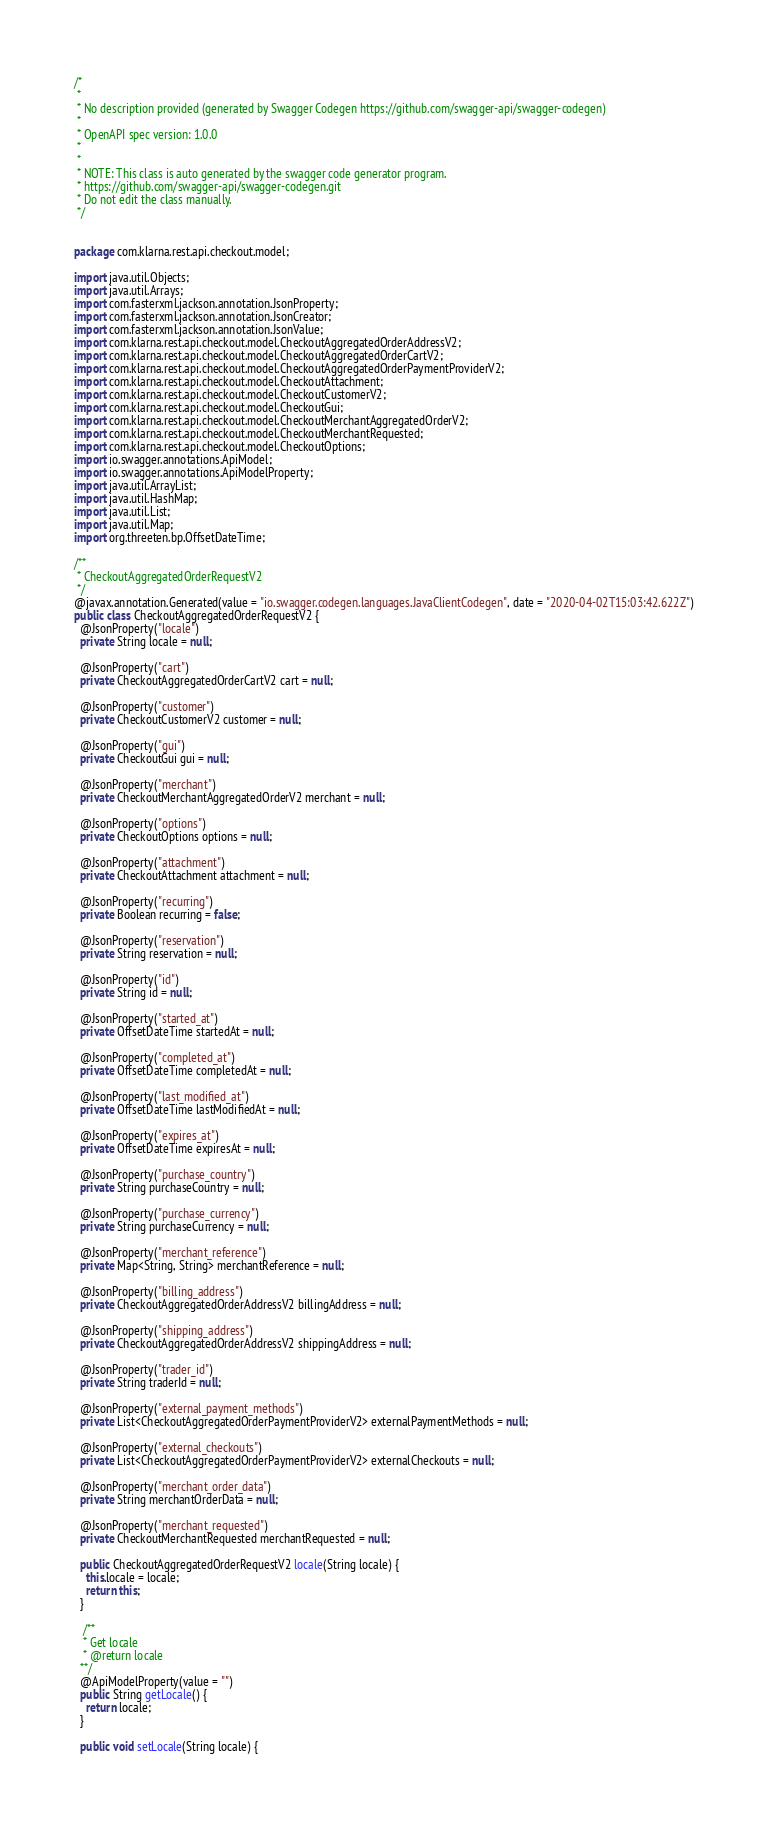Convert code to text. <code><loc_0><loc_0><loc_500><loc_500><_Java_>/*
 * 
 * No description provided (generated by Swagger Codegen https://github.com/swagger-api/swagger-codegen)
 *
 * OpenAPI spec version: 1.0.0
 * 
 *
 * NOTE: This class is auto generated by the swagger code generator program.
 * https://github.com/swagger-api/swagger-codegen.git
 * Do not edit the class manually.
 */


package com.klarna.rest.api.checkout.model;

import java.util.Objects;
import java.util.Arrays;
import com.fasterxml.jackson.annotation.JsonProperty;
import com.fasterxml.jackson.annotation.JsonCreator;
import com.fasterxml.jackson.annotation.JsonValue;
import com.klarna.rest.api.checkout.model.CheckoutAggregatedOrderAddressV2;
import com.klarna.rest.api.checkout.model.CheckoutAggregatedOrderCartV2;
import com.klarna.rest.api.checkout.model.CheckoutAggregatedOrderPaymentProviderV2;
import com.klarna.rest.api.checkout.model.CheckoutAttachment;
import com.klarna.rest.api.checkout.model.CheckoutCustomerV2;
import com.klarna.rest.api.checkout.model.CheckoutGui;
import com.klarna.rest.api.checkout.model.CheckoutMerchantAggregatedOrderV2;
import com.klarna.rest.api.checkout.model.CheckoutMerchantRequested;
import com.klarna.rest.api.checkout.model.CheckoutOptions;
import io.swagger.annotations.ApiModel;
import io.swagger.annotations.ApiModelProperty;
import java.util.ArrayList;
import java.util.HashMap;
import java.util.List;
import java.util.Map;
import org.threeten.bp.OffsetDateTime;

/**
 * CheckoutAggregatedOrderRequestV2
 */
@javax.annotation.Generated(value = "io.swagger.codegen.languages.JavaClientCodegen", date = "2020-04-02T15:03:42.622Z")
public class CheckoutAggregatedOrderRequestV2 {
  @JsonProperty("locale")
  private String locale = null;

  @JsonProperty("cart")
  private CheckoutAggregatedOrderCartV2 cart = null;

  @JsonProperty("customer")
  private CheckoutCustomerV2 customer = null;

  @JsonProperty("gui")
  private CheckoutGui gui = null;

  @JsonProperty("merchant")
  private CheckoutMerchantAggregatedOrderV2 merchant = null;

  @JsonProperty("options")
  private CheckoutOptions options = null;

  @JsonProperty("attachment")
  private CheckoutAttachment attachment = null;

  @JsonProperty("recurring")
  private Boolean recurring = false;

  @JsonProperty("reservation")
  private String reservation = null;

  @JsonProperty("id")
  private String id = null;

  @JsonProperty("started_at")
  private OffsetDateTime startedAt = null;

  @JsonProperty("completed_at")
  private OffsetDateTime completedAt = null;

  @JsonProperty("last_modified_at")
  private OffsetDateTime lastModifiedAt = null;

  @JsonProperty("expires_at")
  private OffsetDateTime expiresAt = null;

  @JsonProperty("purchase_country")
  private String purchaseCountry = null;

  @JsonProperty("purchase_currency")
  private String purchaseCurrency = null;

  @JsonProperty("merchant_reference")
  private Map<String, String> merchantReference = null;

  @JsonProperty("billing_address")
  private CheckoutAggregatedOrderAddressV2 billingAddress = null;

  @JsonProperty("shipping_address")
  private CheckoutAggregatedOrderAddressV2 shippingAddress = null;

  @JsonProperty("trader_id")
  private String traderId = null;

  @JsonProperty("external_payment_methods")
  private List<CheckoutAggregatedOrderPaymentProviderV2> externalPaymentMethods = null;

  @JsonProperty("external_checkouts")
  private List<CheckoutAggregatedOrderPaymentProviderV2> externalCheckouts = null;

  @JsonProperty("merchant_order_data")
  private String merchantOrderData = null;

  @JsonProperty("merchant_requested")
  private CheckoutMerchantRequested merchantRequested = null;

  public CheckoutAggregatedOrderRequestV2 locale(String locale) {
    this.locale = locale;
    return this;
  }

   /**
   * Get locale
   * @return locale
  **/
  @ApiModelProperty(value = "")
  public String getLocale() {
    return locale;
  }

  public void setLocale(String locale) {</code> 